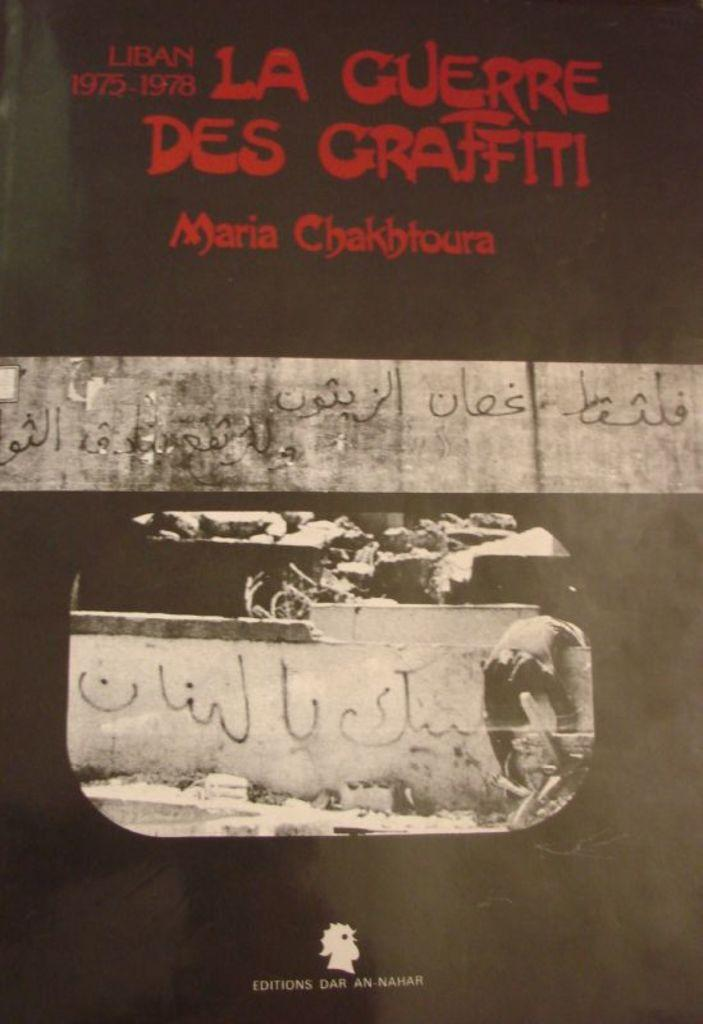<image>
Summarize the visual content of the image. Black background with red words that say "La Cuerre Des Graffiti". 